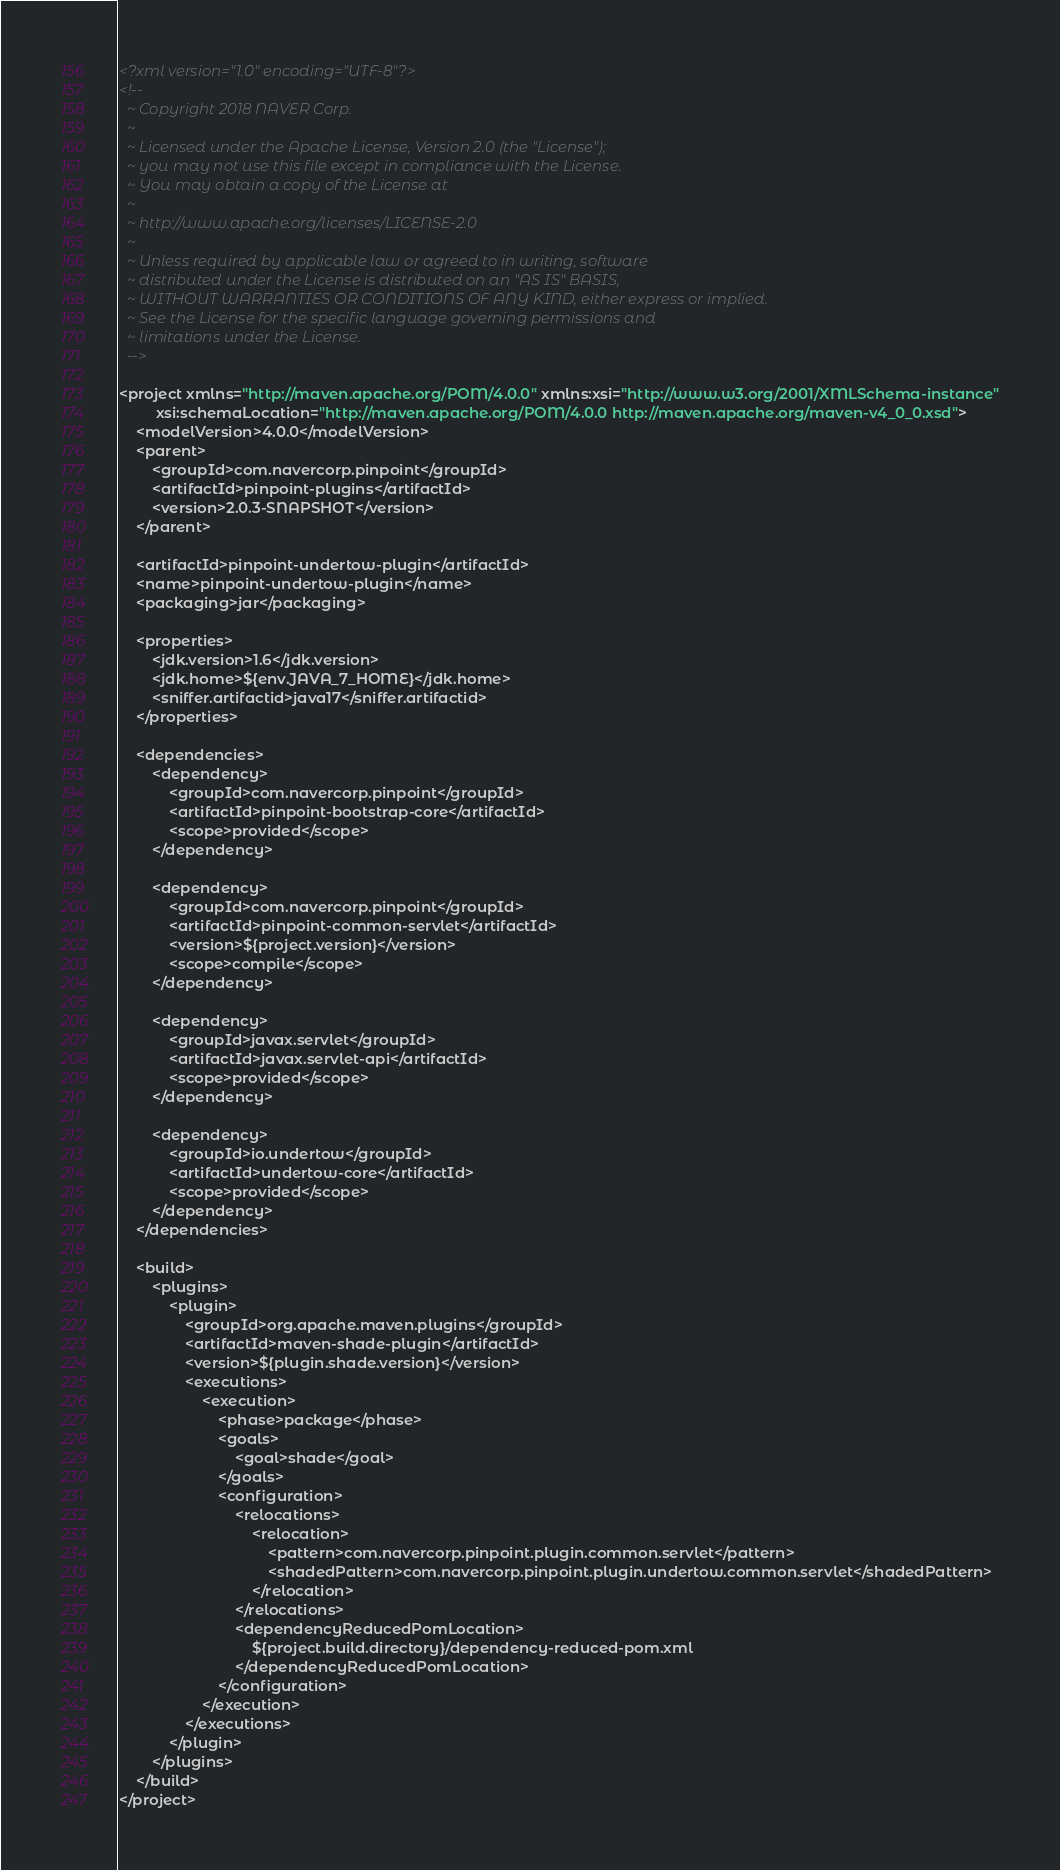<code> <loc_0><loc_0><loc_500><loc_500><_XML_><?xml version="1.0" encoding="UTF-8"?>
<!--
  ~ Copyright 2018 NAVER Corp.
  ~
  ~ Licensed under the Apache License, Version 2.0 (the "License");
  ~ you may not use this file except in compliance with the License.
  ~ You may obtain a copy of the License at
  ~
  ~ http://www.apache.org/licenses/LICENSE-2.0
  ~
  ~ Unless required by applicable law or agreed to in writing, software
  ~ distributed under the License is distributed on an "AS IS" BASIS,
  ~ WITHOUT WARRANTIES OR CONDITIONS OF ANY KIND, either express or implied.
  ~ See the License for the specific language governing permissions and
  ~ limitations under the License.
  -->

<project xmlns="http://maven.apache.org/POM/4.0.0" xmlns:xsi="http://www.w3.org/2001/XMLSchema-instance"
         xsi:schemaLocation="http://maven.apache.org/POM/4.0.0 http://maven.apache.org/maven-v4_0_0.xsd">
    <modelVersion>4.0.0</modelVersion>
    <parent>
        <groupId>com.navercorp.pinpoint</groupId>
        <artifactId>pinpoint-plugins</artifactId>
        <version>2.0.3-SNAPSHOT</version>
    </parent>

    <artifactId>pinpoint-undertow-plugin</artifactId>
    <name>pinpoint-undertow-plugin</name>
    <packaging>jar</packaging>

    <properties>
        <jdk.version>1.6</jdk.version>
        <jdk.home>${env.JAVA_7_HOME}</jdk.home>
        <sniffer.artifactid>java17</sniffer.artifactid>
    </properties>

    <dependencies>
        <dependency>
            <groupId>com.navercorp.pinpoint</groupId>
            <artifactId>pinpoint-bootstrap-core</artifactId>
            <scope>provided</scope>
        </dependency>

        <dependency>
            <groupId>com.navercorp.pinpoint</groupId>
            <artifactId>pinpoint-common-servlet</artifactId>
            <version>${project.version}</version>
            <scope>compile</scope>
        </dependency>

        <dependency>
            <groupId>javax.servlet</groupId>
            <artifactId>javax.servlet-api</artifactId>
            <scope>provided</scope>
        </dependency>

        <dependency>
            <groupId>io.undertow</groupId>
            <artifactId>undertow-core</artifactId>
            <scope>provided</scope>
        </dependency>
    </dependencies>

    <build>
        <plugins>
            <plugin>
                <groupId>org.apache.maven.plugins</groupId>
                <artifactId>maven-shade-plugin</artifactId>
                <version>${plugin.shade.version}</version>
                <executions>
                    <execution>
                        <phase>package</phase>
                        <goals>
                            <goal>shade</goal>
                        </goals>
                        <configuration>
                            <relocations>
                                <relocation>
                                    <pattern>com.navercorp.pinpoint.plugin.common.servlet</pattern>
                                    <shadedPattern>com.navercorp.pinpoint.plugin.undertow.common.servlet</shadedPattern>
                                </relocation>
                            </relocations>
                            <dependencyReducedPomLocation>
                                ${project.build.directory}/dependency-reduced-pom.xml
                            </dependencyReducedPomLocation>
                        </configuration>
                    </execution>
                </executions>
            </plugin>
        </plugins>
    </build>
</project>
</code> 